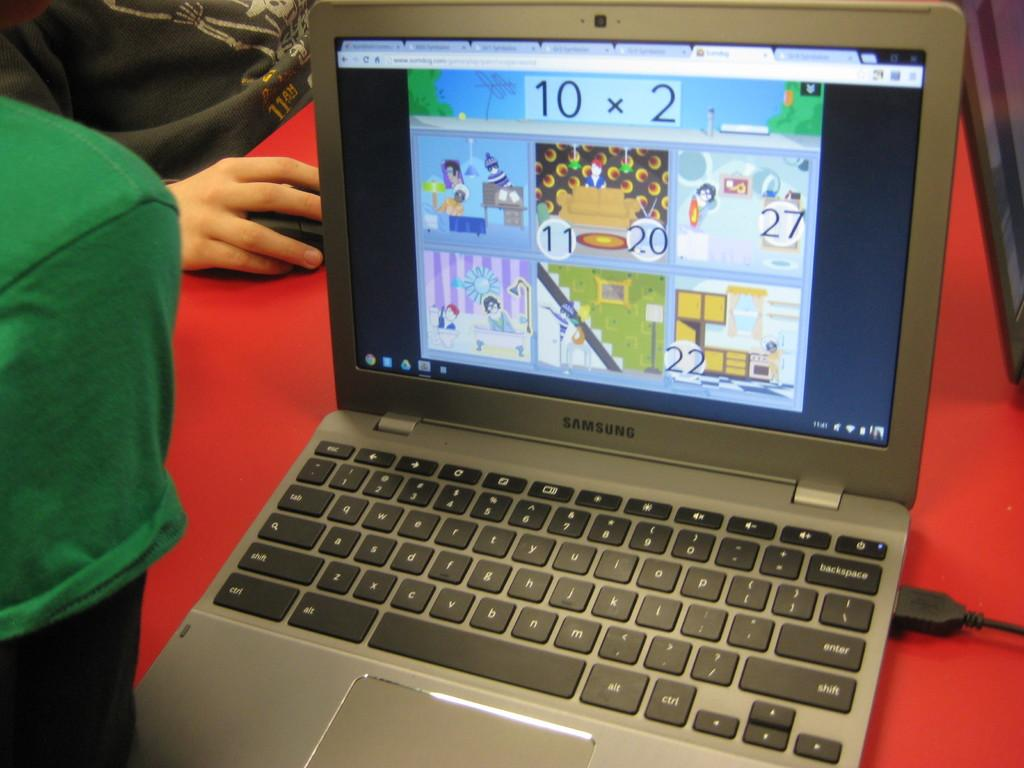<image>
Write a terse but informative summary of the picture. An open laptop with a game on the screen showing 10 x 2 at the top of the screen . 